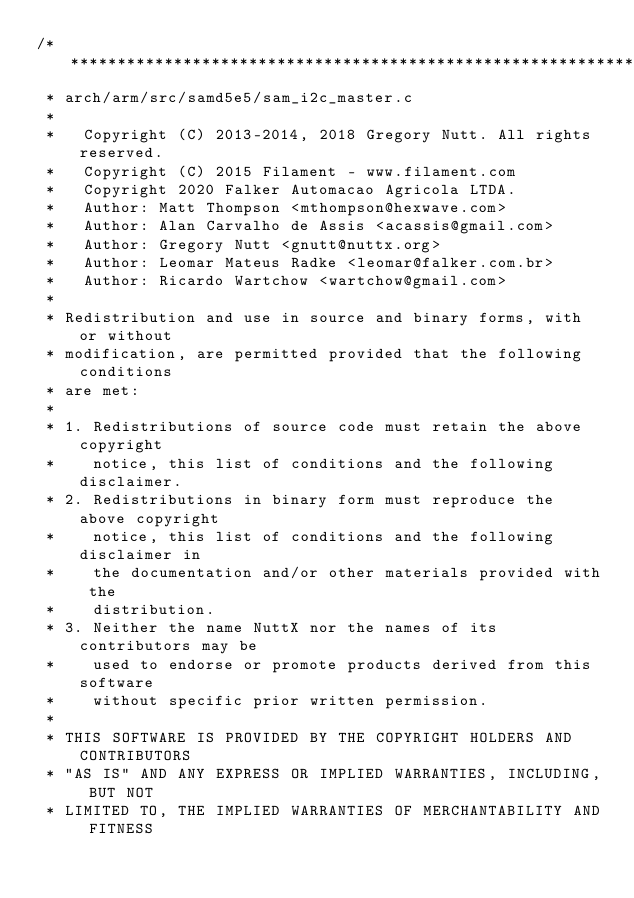Convert code to text. <code><loc_0><loc_0><loc_500><loc_500><_C_>/****************************************************************************
 * arch/arm/src/samd5e5/sam_i2c_master.c
 *
 *   Copyright (C) 2013-2014, 2018 Gregory Nutt. All rights reserved.
 *   Copyright (C) 2015 Filament - www.filament.com
 *   Copyright 2020 Falker Automacao Agricola LTDA.
 *   Author: Matt Thompson <mthompson@hexwave.com>
 *   Author: Alan Carvalho de Assis <acassis@gmail.com>
 *   Author: Gregory Nutt <gnutt@nuttx.org>
 *   Author: Leomar Mateus Radke <leomar@falker.com.br>
 *   Author: Ricardo Wartchow <wartchow@gmail.com>
 *
 * Redistribution and use in source and binary forms, with or without
 * modification, are permitted provided that the following conditions
 * are met:
 *
 * 1. Redistributions of source code must retain the above copyright
 *    notice, this list of conditions and the following disclaimer.
 * 2. Redistributions in binary form must reproduce the above copyright
 *    notice, this list of conditions and the following disclaimer in
 *    the documentation and/or other materials provided with the
 *    distribution.
 * 3. Neither the name NuttX nor the names of its contributors may be
 *    used to endorse or promote products derived from this software
 *    without specific prior written permission.
 *
 * THIS SOFTWARE IS PROVIDED BY THE COPYRIGHT HOLDERS AND CONTRIBUTORS
 * "AS IS" AND ANY EXPRESS OR IMPLIED WARRANTIES, INCLUDING, BUT NOT
 * LIMITED TO, THE IMPLIED WARRANTIES OF MERCHANTABILITY AND FITNESS</code> 